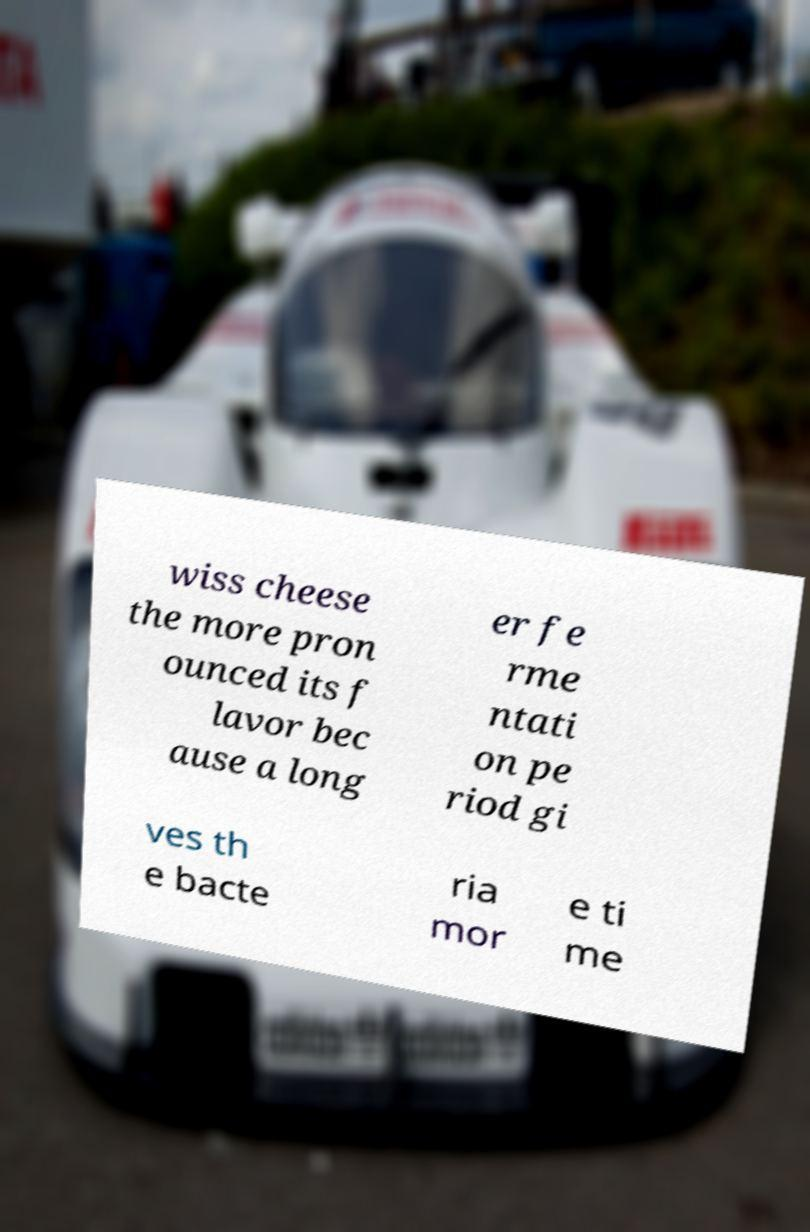Please read and relay the text visible in this image. What does it say? wiss cheese the more pron ounced its f lavor bec ause a long er fe rme ntati on pe riod gi ves th e bacte ria mor e ti me 